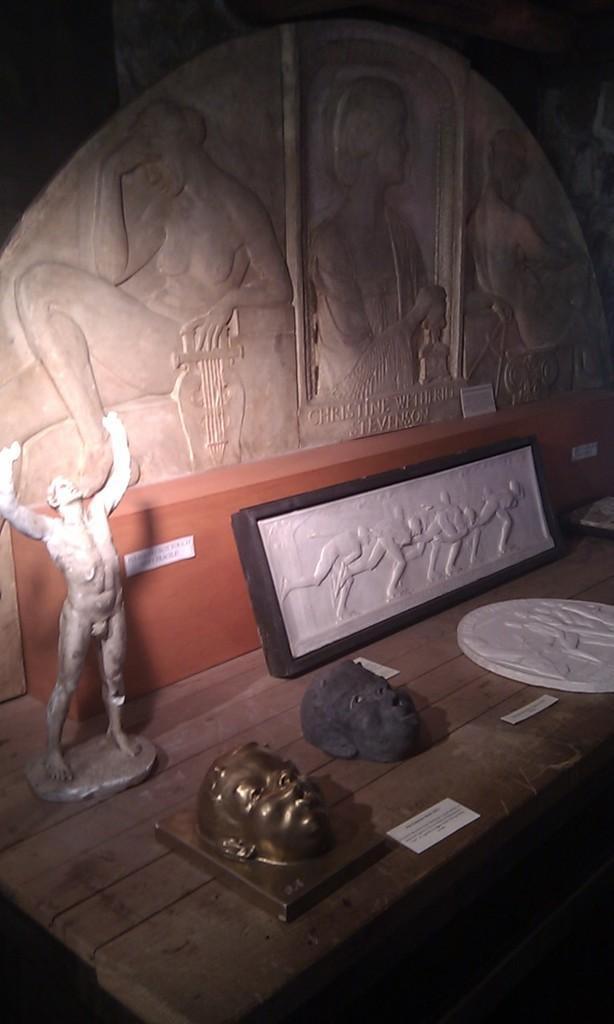In one or two sentences, can you explain what this image depicts? In this image there is a table and we can see sculptures placed on the table. In the background there is a wall and we can see carving on the wall. 